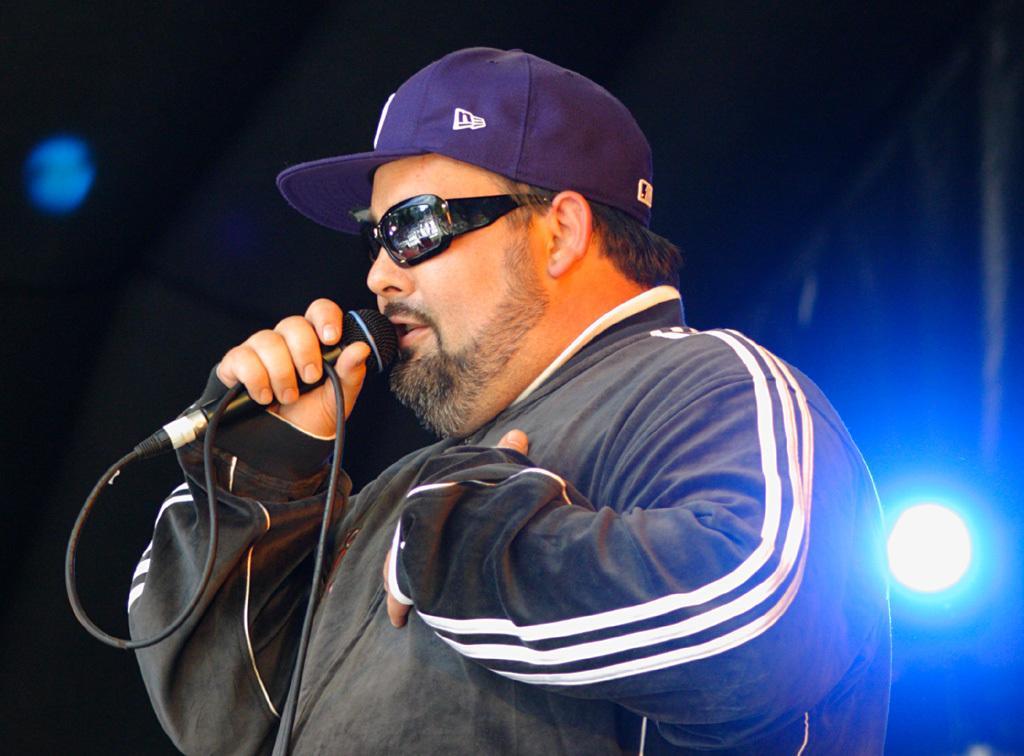Describe this image in one or two sentences. Here we can see a man holding a microphone probably singing, he is wearing goggles and Cap in behind him we can see fancy lights 